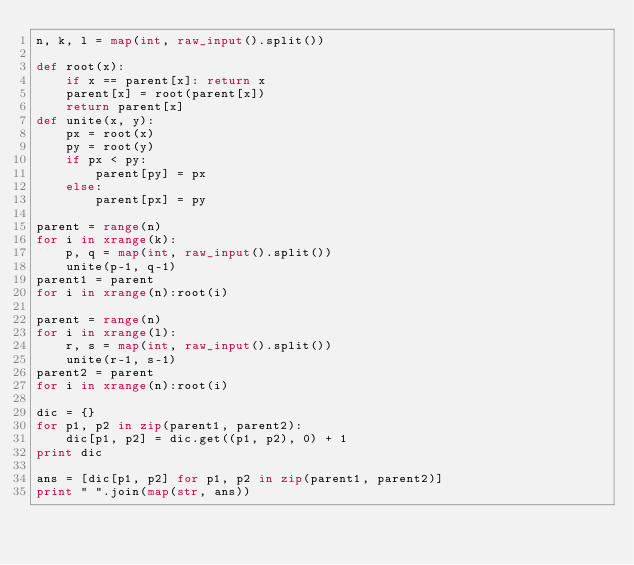<code> <loc_0><loc_0><loc_500><loc_500><_Python_>n, k, l = map(int, raw_input().split())

def root(x):
    if x == parent[x]: return x
    parent[x] = root(parent[x])
    return parent[x]
def unite(x, y):
    px = root(x)
    py = root(y)
    if px < py:
        parent[py] = px
    else:
        parent[px] = py

parent = range(n)
for i in xrange(k):
    p, q = map(int, raw_input().split())
    unite(p-1, q-1)
parent1 = parent
for i in xrange(n):root(i)

parent = range(n)
for i in xrange(l):
    r, s = map(int, raw_input().split())
    unite(r-1, s-1)
parent2 = parent
for i in xrange(n):root(i)

dic = {}
for p1, p2 in zip(parent1, parent2):
    dic[p1, p2] = dic.get((p1, p2), 0) + 1
print dic

ans = [dic[p1, p2] for p1, p2 in zip(parent1, parent2)]
print " ".join(map(str, ans))
</code> 